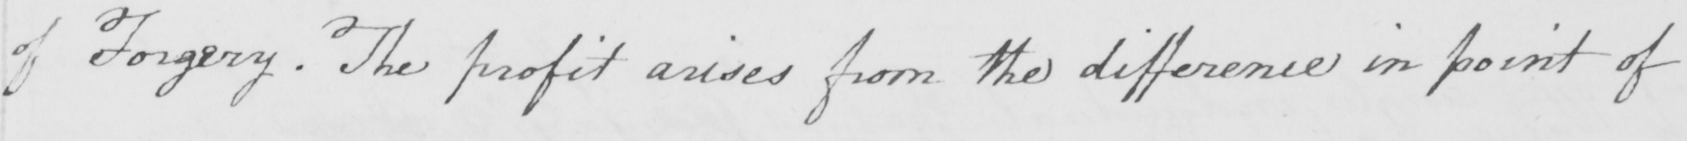Transcribe the text shown in this historical manuscript line. of Forgery . The profit arises from the difference in point of 